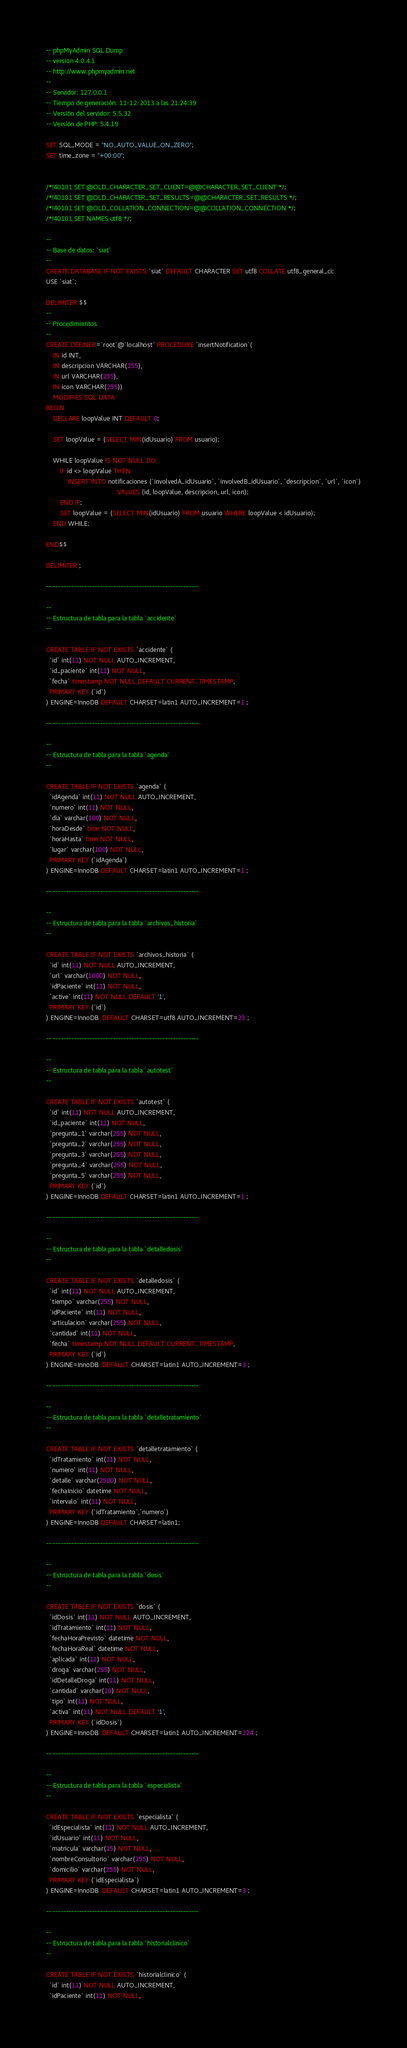<code> <loc_0><loc_0><loc_500><loc_500><_SQL_>-- phpMyAdmin SQL Dump
-- version 4.0.4.1
-- http://www.phpmyadmin.net
--
-- Servidor: 127.0.0.1
-- Tiempo de generación: 11-12-2013 a las 21:24:39
-- Versión del servidor: 5.5.32
-- Versión de PHP: 5.4.19

SET SQL_MODE = "NO_AUTO_VALUE_ON_ZERO";
SET time_zone = "+00:00";


/*!40101 SET @OLD_CHARACTER_SET_CLIENT=@@CHARACTER_SET_CLIENT */;
/*!40101 SET @OLD_CHARACTER_SET_RESULTS=@@CHARACTER_SET_RESULTS */;
/*!40101 SET @OLD_COLLATION_CONNECTION=@@COLLATION_CONNECTION */;
/*!40101 SET NAMES utf8 */;

--
-- Base de datos: `siat`
--
CREATE DATABASE IF NOT EXISTS `siat` DEFAULT CHARACTER SET utf8 COLLATE utf8_general_ci;
USE `siat`;

DELIMITER $$
--
-- Procedimientos
--
CREATE DEFINER=`root`@`localhost` PROCEDURE `insertNotification`(
    IN id INT,
	IN descripcion VARCHAR(255),
	IN url VARCHAR(255),
	IN icon VARCHAR(255))
    MODIFIES SQL DATA
BEGIN 
	DECLARE loopValue INT DEFAULT 0;
	
	SET loopValue = (SELECT MIN(idUsuario) FROM usuario);

	WHILE loopValue IS NOT NULL DO
		IF id <> loopValue THEN
			INSERT INTO notificaciones (`involvedA_idUsuario`, `involvedB_idUsuario`, `descripcion`, `url`, `icon`)
										VALUES (id, loopValue, descripcion, url, icon);
		END IF;
		SET loopValue = (SELECT MIN(idUsuario) FROM usuario WHERE loopValue < idUsuario);
	END WHILE;

END$$

DELIMITER ;

-- --------------------------------------------------------

--
-- Estructura de tabla para la tabla `accidente`
--

CREATE TABLE IF NOT EXISTS `accidente` (
  `id` int(11) NOT NULL AUTO_INCREMENT,
  `id_paciente` int(11) NOT NULL,
  `fecha` timestamp NOT NULL DEFAULT CURRENT_TIMESTAMP,
  PRIMARY KEY (`id`)
) ENGINE=InnoDB DEFAULT CHARSET=latin1 AUTO_INCREMENT=1 ;

-- --------------------------------------------------------

--
-- Estructura de tabla para la tabla `agenda`
--

CREATE TABLE IF NOT EXISTS `agenda` (
  `idAgenda` int(11) NOT NULL AUTO_INCREMENT,
  `numero` int(11) NOT NULL,
  `dia` varchar(100) NOT NULL,
  `horaDesde` time NOT NULL,
  `horaHasta` time NOT NULL,
  `lugar` varchar(100) NOT NULL,
  PRIMARY KEY (`idAgenda`)
) ENGINE=InnoDB DEFAULT CHARSET=latin1 AUTO_INCREMENT=1 ;

-- --------------------------------------------------------

--
-- Estructura de tabla para la tabla `archivos_historia`
--

CREATE TABLE IF NOT EXISTS `archivos_historia` (
  `id` int(11) NOT NULL AUTO_INCREMENT,
  `url` varchar(1000) NOT NULL,
  `idPaciente` int(11) NOT NULL,
  `active` int(11) NOT NULL DEFAULT '1',
  PRIMARY KEY (`id`)
) ENGINE=InnoDB  DEFAULT CHARSET=utf8 AUTO_INCREMENT=23 ;

-- --------------------------------------------------------

--
-- Estructura de tabla para la tabla `autotest`
--

CREATE TABLE IF NOT EXISTS `autotest` (
  `id` int(11) NOT NULL AUTO_INCREMENT,
  `id_paciente` int(11) NOT NULL,
  `pregunta_1` varchar(255) NOT NULL,
  `pregunta_2` varchar(255) NOT NULL,
  `pregunta_3` varchar(255) NOT NULL,
  `pregunta_4` varchar(255) NOT NULL,
  `pregunta_5` varchar(255) NOT NULL,
  PRIMARY KEY (`id`)
) ENGINE=InnoDB DEFAULT CHARSET=latin1 AUTO_INCREMENT=1 ;

-- --------------------------------------------------------

--
-- Estructura de tabla para la tabla `detalledosis`
--

CREATE TABLE IF NOT EXISTS `detalledosis` (
  `id` int(11) NOT NULL AUTO_INCREMENT,
  `tiempo` varchar(255) NOT NULL,
  `idPaciente` int(11) NOT NULL,
  `articulacion` varchar(255) NOT NULL,
  `cantidad` int(11) NOT NULL,
  `fecha` timestamp NOT NULL DEFAULT CURRENT_TIMESTAMP,
  PRIMARY KEY (`id`)
) ENGINE=InnoDB  DEFAULT CHARSET=latin1 AUTO_INCREMENT=3 ;

-- --------------------------------------------------------

--
-- Estructura de tabla para la tabla `detalletratamiento`
--

CREATE TABLE IF NOT EXISTS `detalletratamiento` (
  `idTratamiento` int(11) NOT NULL,
  `numero` int(11) NOT NULL,
  `detalle` varchar(2500) NOT NULL,
  `fechaInicio` datetime NOT NULL,
  `intervalo` int(11) NOT NULL,
  PRIMARY KEY (`idTratamiento`,`numero`)
) ENGINE=InnoDB DEFAULT CHARSET=latin1;

-- --------------------------------------------------------

--
-- Estructura de tabla para la tabla `dosis`
--

CREATE TABLE IF NOT EXISTS `dosis` (
  `idDosis` int(11) NOT NULL AUTO_INCREMENT,
  `idTratamiento` int(11) NOT NULL,
  `fechaHoraPrevisto` datetime NOT NULL,
  `fechaHoraReal` datetime NOT NULL,
  `aplicada` int(11) NOT NULL,
  `droga` varchar(255) NOT NULL,
  `idDetalleDroga` int(11) NOT NULL,
  `cantidad` varchar(10) NOT NULL,
  `tipo` int(11) NOT NULL,
  `activa` int(11) NOT NULL DEFAULT '1',
  PRIMARY KEY (`idDosis`)
) ENGINE=InnoDB  DEFAULT CHARSET=latin1 AUTO_INCREMENT=224 ;

-- --------------------------------------------------------

--
-- Estructura de tabla para la tabla `especialista`
--

CREATE TABLE IF NOT EXISTS `especialista` (
  `idEspecialista` int(11) NOT NULL AUTO_INCREMENT,
  `idUsuario` int(11) NOT NULL,
  `matricula` varchar(15) NOT NULL,
  `nombreConsultorio` varchar(255) NOT NULL,
  `domicilio` varchar(255) NOT NULL,
  PRIMARY KEY (`idEspecialista`)
) ENGINE=InnoDB  DEFAULT CHARSET=latin1 AUTO_INCREMENT=3 ;

-- --------------------------------------------------------

--
-- Estructura de tabla para la tabla `historialclinico`
--

CREATE TABLE IF NOT EXISTS `historialclinico` (
  `id` int(11) NOT NULL AUTO_INCREMENT,
  `idPaciente` int(11) NOT NULL,</code> 